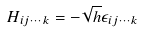<formula> <loc_0><loc_0><loc_500><loc_500>H _ { i j \cdots k } = - \sqrt { h } \epsilon _ { i j \cdots k }</formula> 